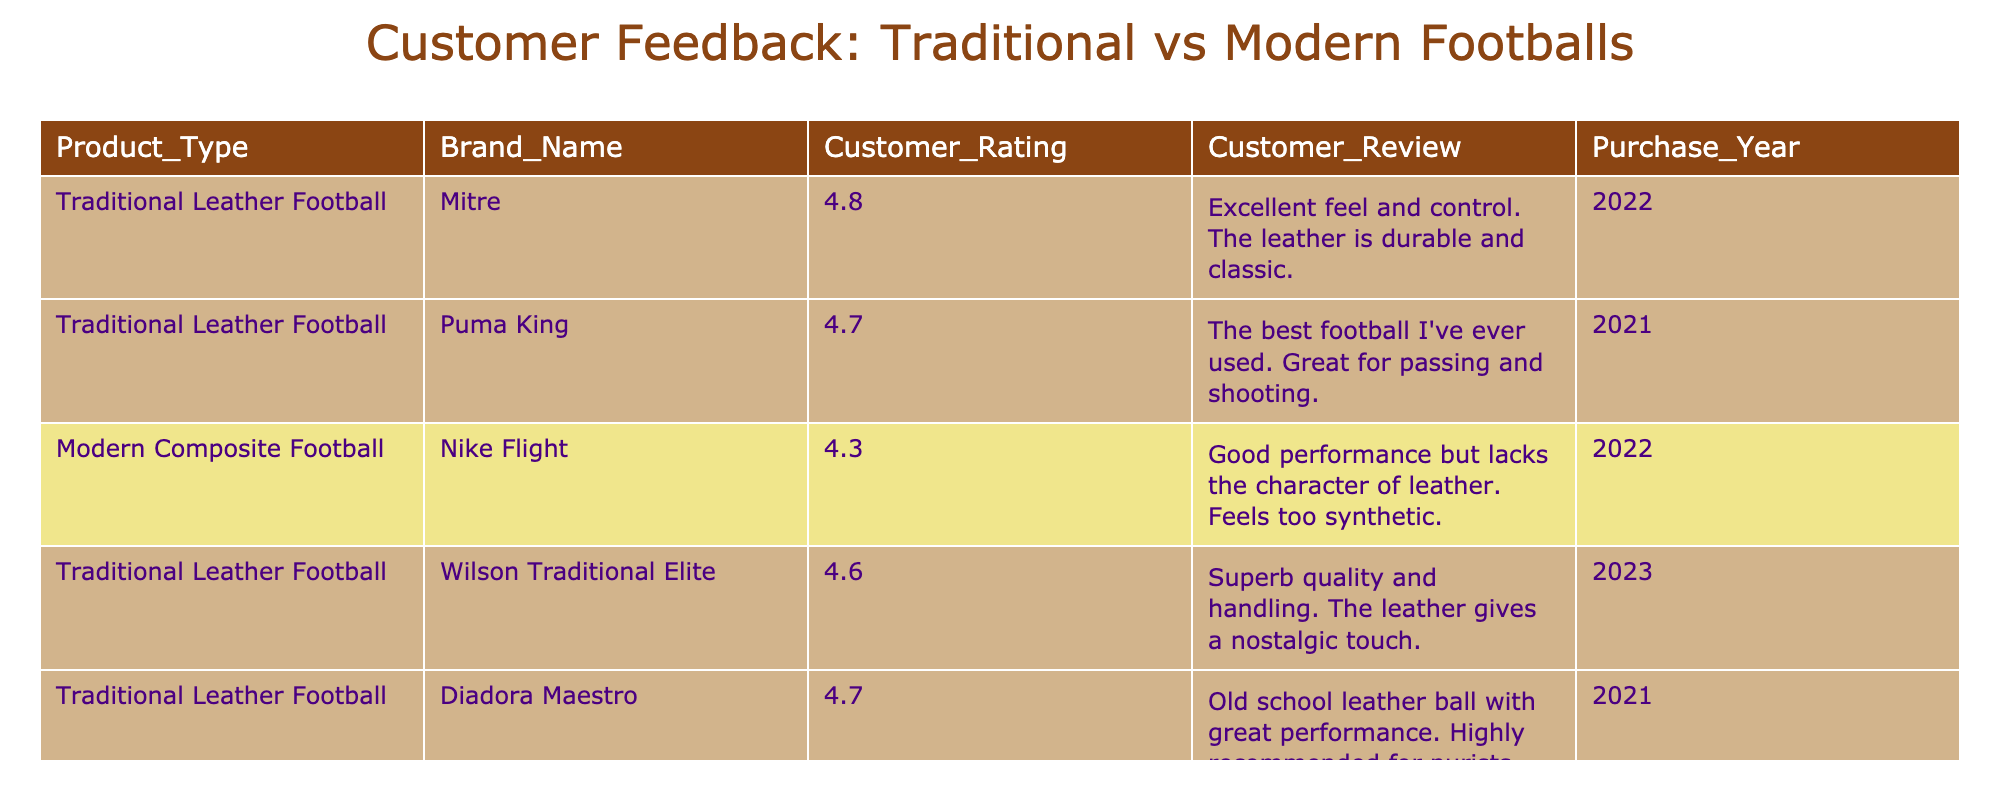What is the highest customer rating for a traditional leather football? The table shows customer ratings for various products. By looking at the ratings for traditional leather footballs, we find the highest rating is 4.8 for the Mitre brand.
Answer: 4.8 Which modern composite football has the lowest customer rating? In the table, there is only one modern composite football listed (Nike Flight) and its customer rating is 4.3. Thus, it is the only one, hence also the lowest.
Answer: 4.3 How many traditional leather footballs received customer ratings above 4.6? From the table, we see that Mitre (4.8), Wilson Traditional Elite (4.6), and Diadora Maestro (4.7) are above 4.6. There are three entries in this category.
Answer: 3 What is the average customer rating for traditional leather footballs? The ratings for traditional leather footballs are 4.8, 4.7, 4.6, and 4.7. To find the average, we sum these ratings (4.8 + 4.7 + 4.6 + 4.7 = 19.8) and divide by the number of footballs (4), which results in an average rating of 19.8/4 = 4.95.
Answer: 4.95 Is it true that all traditional leather footballs have ratings higher than modern composite footballs? The highest rating for a modern composite football (Nike Flight) is 4.3, while the lowest rating for a traditional leather football (Wilson Traditional Elite) is 4.6. All traditional leather footballs exceed the rating of the modern design. Therefore, the statement is true.
Answer: True What percentage of the total footballs listed are traditional leather footballs? There are a total of 5 footballs listed in the table: 4 traditional leather and 1 modern composite. The percentage of traditional leather footballs is (4/5) * 100 = 80%.
Answer: 80% Which brand of traditional leather football has the most recent purchase year? The table shows Wilson Traditional Elite with a purchase year of 2023, which is the most recent compared to other traditional leather footballs.
Answer: Wilson Traditional Elite 